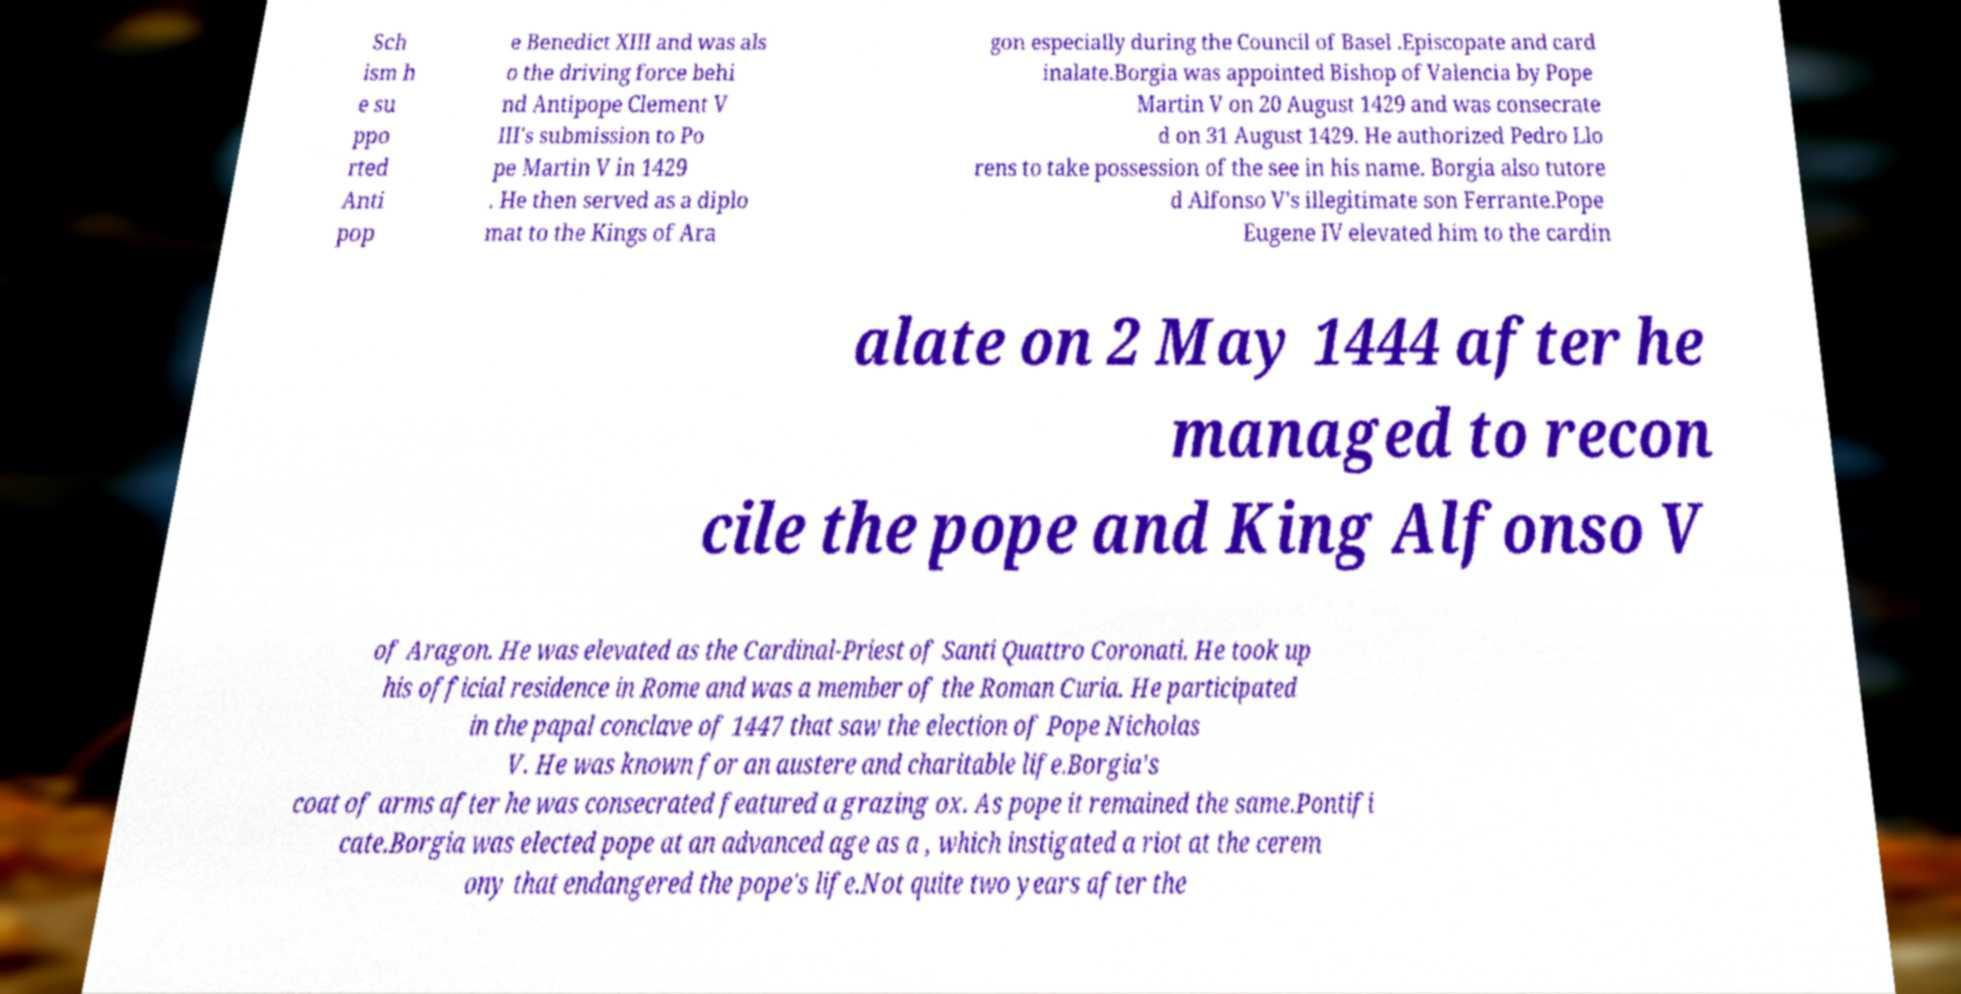Please read and relay the text visible in this image. What does it say? Sch ism h e su ppo rted Anti pop e Benedict XIII and was als o the driving force behi nd Antipope Clement V III's submission to Po pe Martin V in 1429 . He then served as a diplo mat to the Kings of Ara gon especially during the Council of Basel .Episcopate and card inalate.Borgia was appointed Bishop of Valencia by Pope Martin V on 20 August 1429 and was consecrate d on 31 August 1429. He authorized Pedro Llo rens to take possession of the see in his name. Borgia also tutore d Alfonso V's illegitimate son Ferrante.Pope Eugene IV elevated him to the cardin alate on 2 May 1444 after he managed to recon cile the pope and King Alfonso V of Aragon. He was elevated as the Cardinal-Priest of Santi Quattro Coronati. He took up his official residence in Rome and was a member of the Roman Curia. He participated in the papal conclave of 1447 that saw the election of Pope Nicholas V. He was known for an austere and charitable life.Borgia's coat of arms after he was consecrated featured a grazing ox. As pope it remained the same.Pontifi cate.Borgia was elected pope at an advanced age as a , which instigated a riot at the cerem ony that endangered the pope's life.Not quite two years after the 